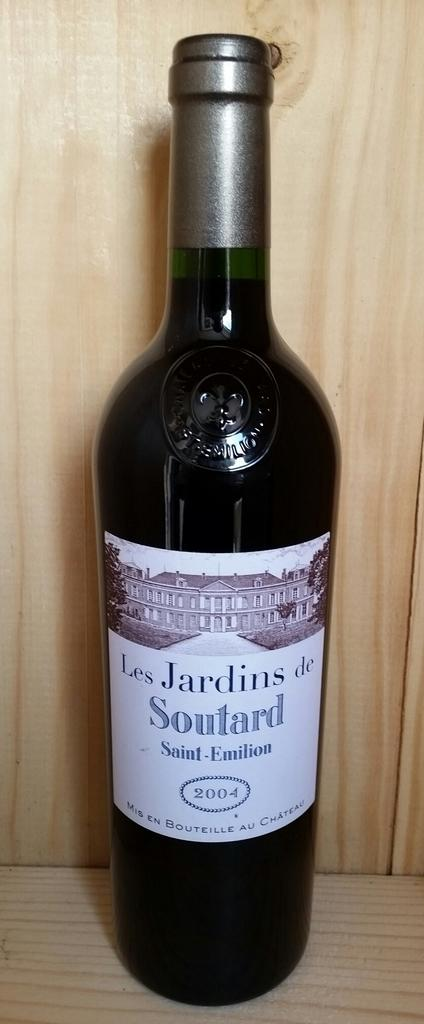What is the main object in the center of the image? There is a wine bottle in the center of the image. What type of material can be seen in the background of the image? There is a wooden wall in the background of the image. What type of material is present in the foreground of the image? There is a wooden foreground in the image. What type of writing can be seen on the wine bottle in the image? There is no writing visible on the wine bottle in the image. What force is being applied to the wine bottle in the image? There is no force being applied to the wine bottle in the image; it is stationary. 